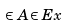Convert formula to latex. <formula><loc_0><loc_0><loc_500><loc_500>\in A { \in E { x } }</formula> 